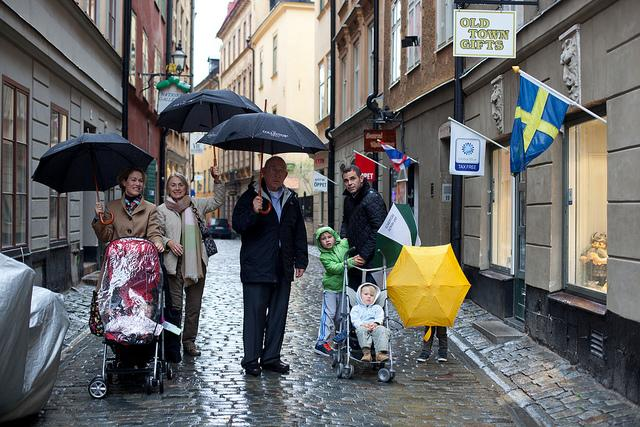What kind of flag is the blue and yellow one? Please explain your reasoning. swedens flag. The flag is sweden's. 